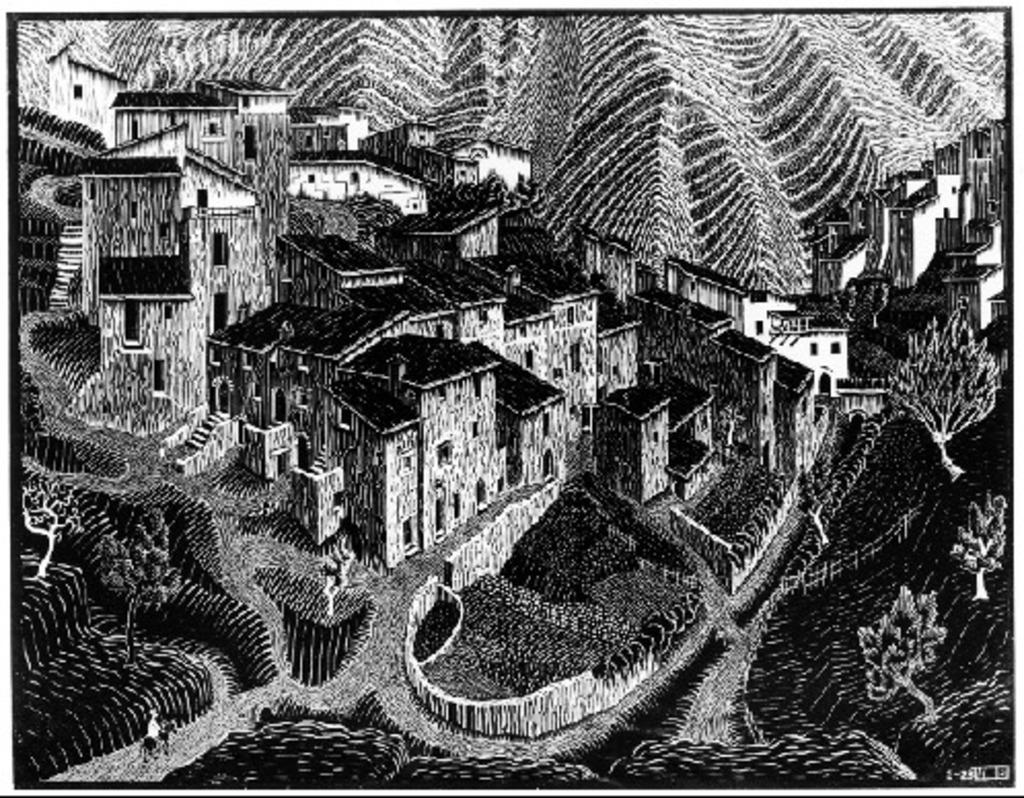What is the main subject of the painting? The main subject of the painting is many buildings. Can you describe any other elements in the painting? Yes, there is a boundary and trees in the painting. What is the back of the painting made of? The back of the painting is not visible in the image, so we cannot determine what it is made of. 